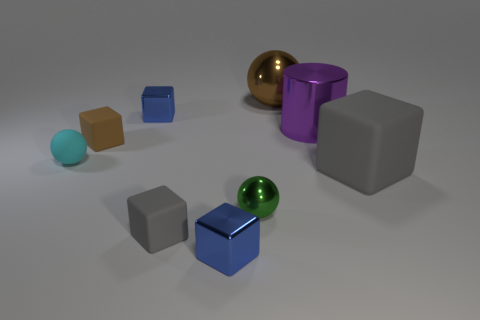How many brown objects are either big matte cubes or rubber cubes?
Ensure brevity in your answer.  1. Is the number of large rubber things that are behind the small cyan thing less than the number of tiny spheres?
Make the answer very short. Yes. There is a blue block in front of the small rubber sphere; what number of big brown spheres are behind it?
Offer a terse response. 1. What number of other objects are there of the same size as the purple cylinder?
Give a very brief answer. 2. How many objects are tiny cyan rubber things or tiny cubes behind the tiny gray matte block?
Ensure brevity in your answer.  3. Are there fewer large metal objects than big metallic spheres?
Your answer should be very brief. No. The thing that is right of the big shiny thing that is in front of the large brown sphere is what color?
Offer a very short reply. Gray. There is a brown thing that is the same shape as the big gray thing; what is it made of?
Make the answer very short. Rubber. What number of shiny objects are small red blocks or tiny gray objects?
Your answer should be compact. 0. Is the brown object in front of the big purple object made of the same material as the tiny green thing in front of the large shiny ball?
Offer a terse response. No. 